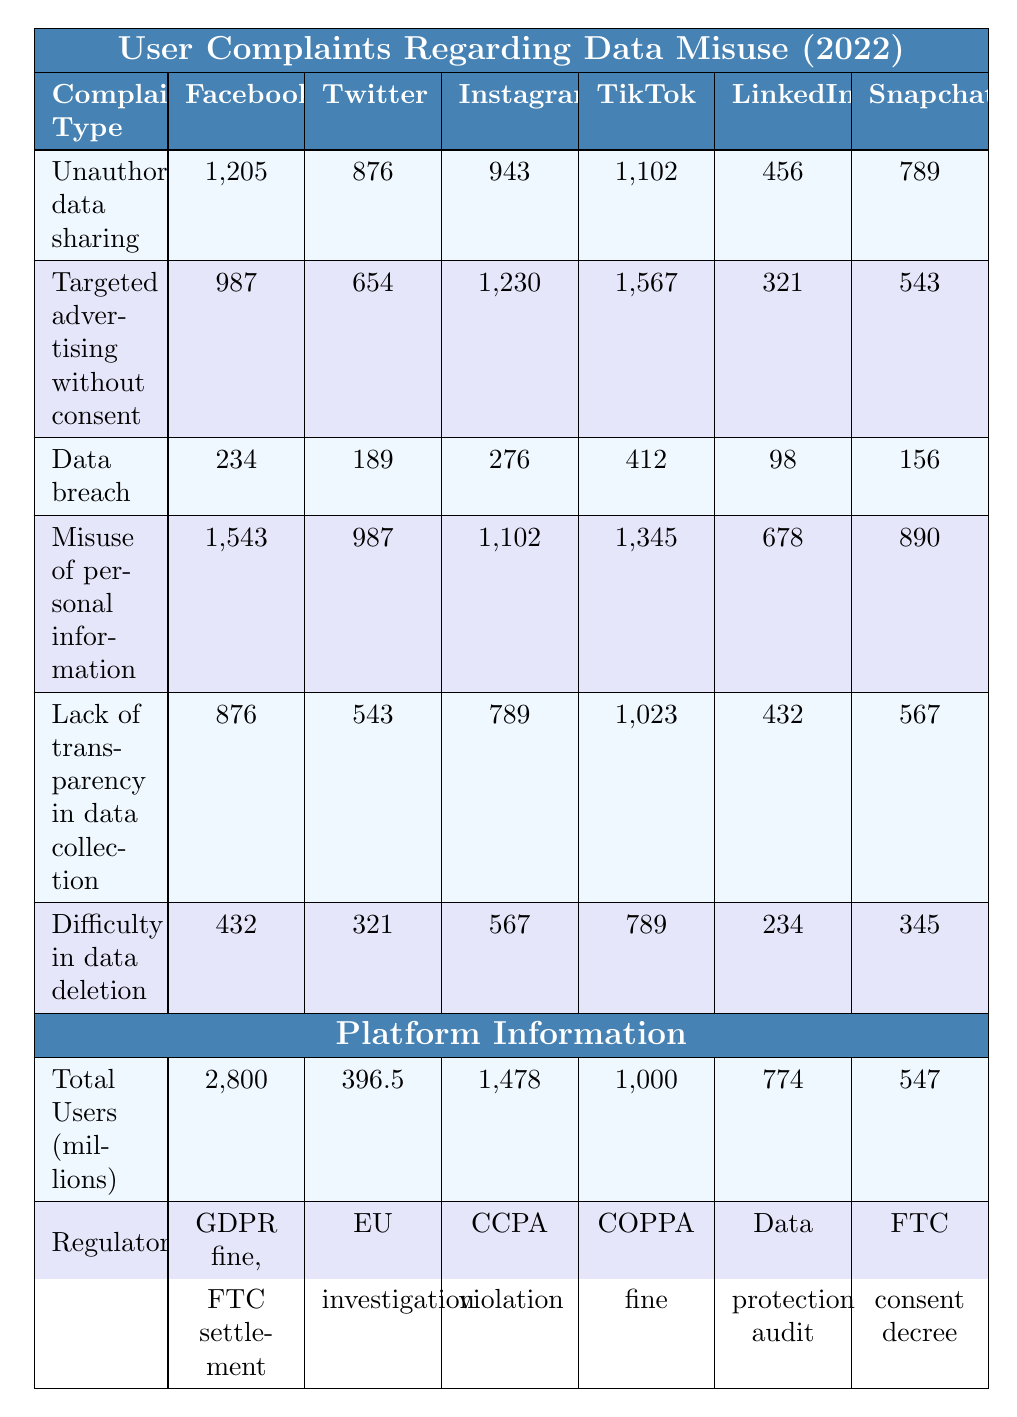What is the highest number of complaints reported for TikTok? The row for TikTok shows the highest number of complaints in the "Targeted advertising without consent" category with 1,567 complaints.
Answer: 1,567 Which social media platform had the most complaints about unauthorized data sharing? Looking at the "Unauthorized data sharing" row, Facebook reported the highest number of complaints with 1,205.
Answer: Facebook How many complaints regarding data breach were reported for LinkedIn? The row for LinkedIn under the "Data breach" category shows 98 complaints.
Answer: 98 What is the total number of complaints for Instagram across all categories? Summing all complaints for Instagram: 943 (unauthorized data sharing) + 1,230 (targeted advertising) + 276 (data breach) + 1,102 (misuse of personal information) + 789 (lack of transparency) + 567 (difficulty in data deletion) gives a total of 4,007.
Answer: 4,007 Which platform had fewer than 500 complaints regarding the misuse of personal information? Instagram had 1,102 complaints for misuse of personal information, while LinkedIn and Snapchat had 678 and 890 respectively, but Facebook (1,543), Twitter (987), and TikTok (1,345) all reported higher than 500 complaints. Thus, no platform had fewer than 500 complaints.
Answer: No What is the average number of complaints regarding "Difficulty in data deletion" across all platforms? The number of complaints for "Difficulty in data deletion" are: 432 (Facebook) + 321 (Twitter) + 567 (Instagram) + 789 (TikTok) + 234 (LinkedIn) + 345 (Snapchat) = 2,688. There are 6 platforms, so the average is 2,688 / 6 = 448.
Answer: 448 Which platform had the least total users among those listed? The total users for each platform are as follows: Facebook (2,800 million), Twitter (396.5 million), Instagram (1,478 million), TikTok (1,000 million), LinkedIn (774 million), and Snapchat (547 million). Twitter has the least with 396.5 million.
Answer: Twitter Are there any platforms that faced regulatory actions related to targeted advertising? Looking at the "Regulatory Actions" section, no specific actions are mentioned directly related to targeted advertising, indicating there were none recorded.
Answer: No What is the difference in complaints regarding targeted advertising without consent between TikTok and LinkedIn? TikTok has 1,567 complaints and LinkedIn has 321 complaints regarding targeted advertising. The difference is 1,567 - 321 = 1,246.
Answer: 1,246 Which type of complaint had the highest number across all platforms? The highest number of complaints across all types is for "Misuse of personal information" with a total of 1,543 (Facebook) + 987 (Twitter) + 1,102 (Instagram) + 1,345 (TikTok) + 678 (LinkedIn) + 890 (Snapchat) = 6,545.
Answer: 6,545 